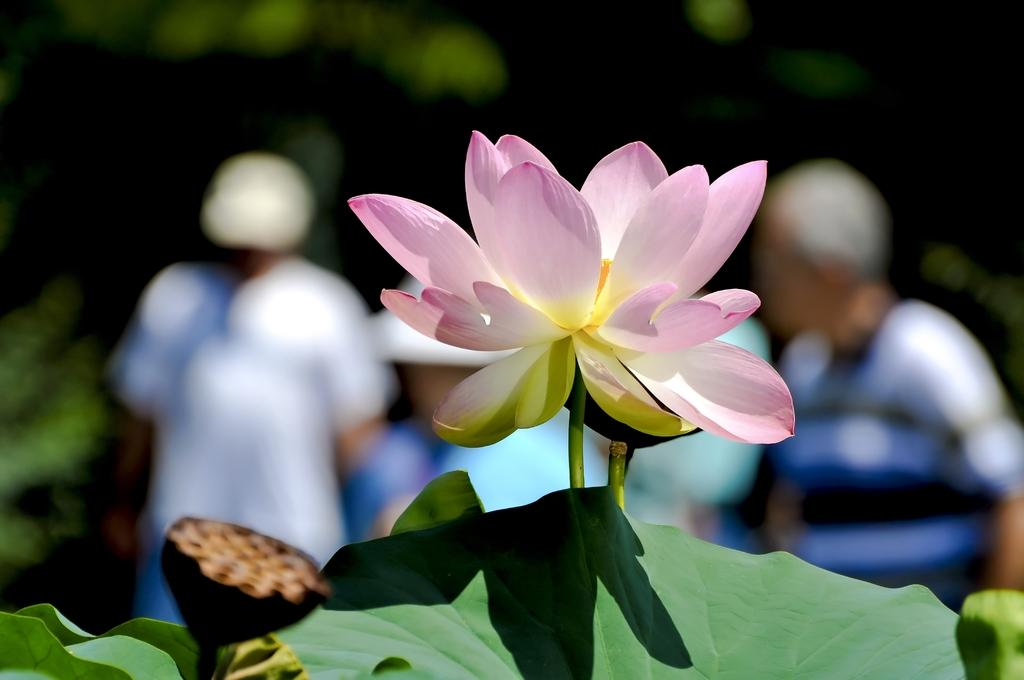What type of flower is present in the image? There is a lotus flower on a plant in the image. How would you describe the background of the image? The background appears blurry. Can you identify any other subjects in the image besides the lotus flower? Yes, there are people visible in the background. What type of reaction can be seen from the lotus flower when a plane flies overhead? There is no plane present in the image, and therefore no reaction from the lotus flower can be observed. 